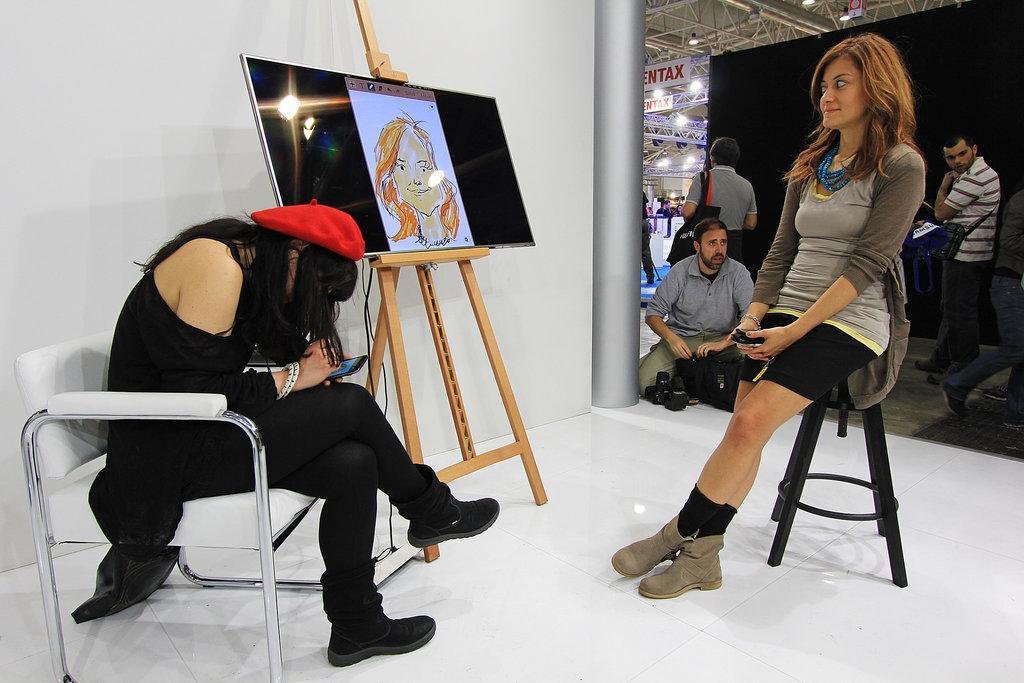Please provide a concise description of this image. In this image we can see two ladies sitting on the chairs. There is a screen on the wooden stand. At the bottom of the image there is a white color surface. To the right side of the image there are people. There is a black color wall. There are rods and banners. In the background of the image there is a white color wall. 